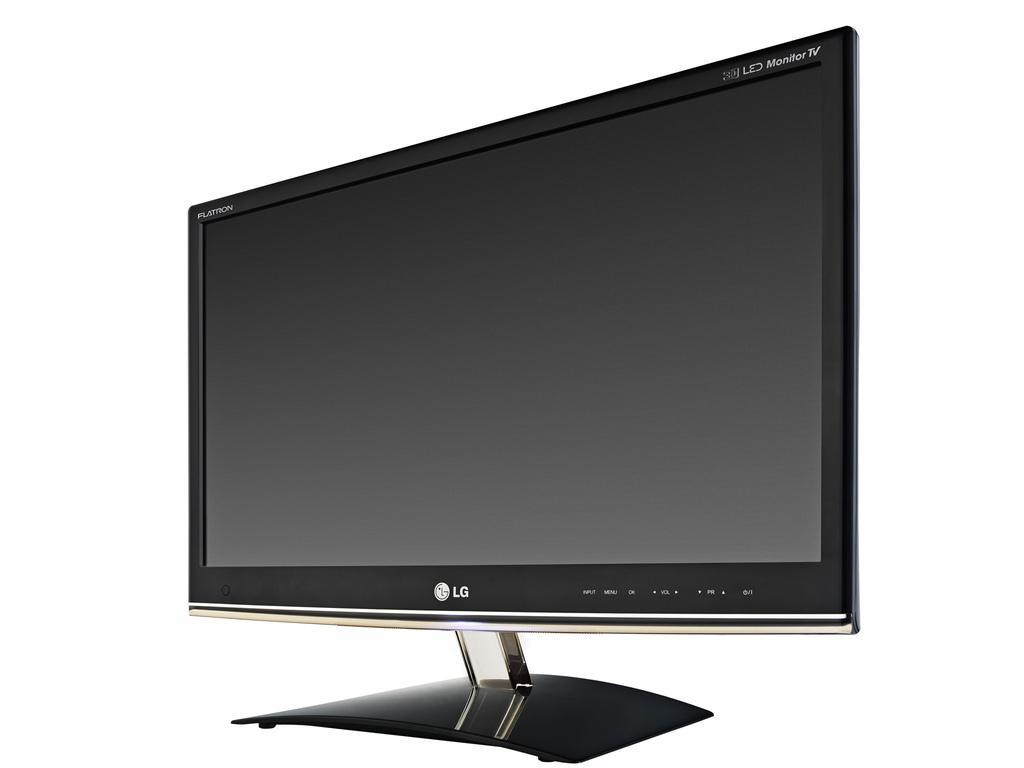Can you describe this image briefly? In this image we can see a television with some text placed on the surface. 